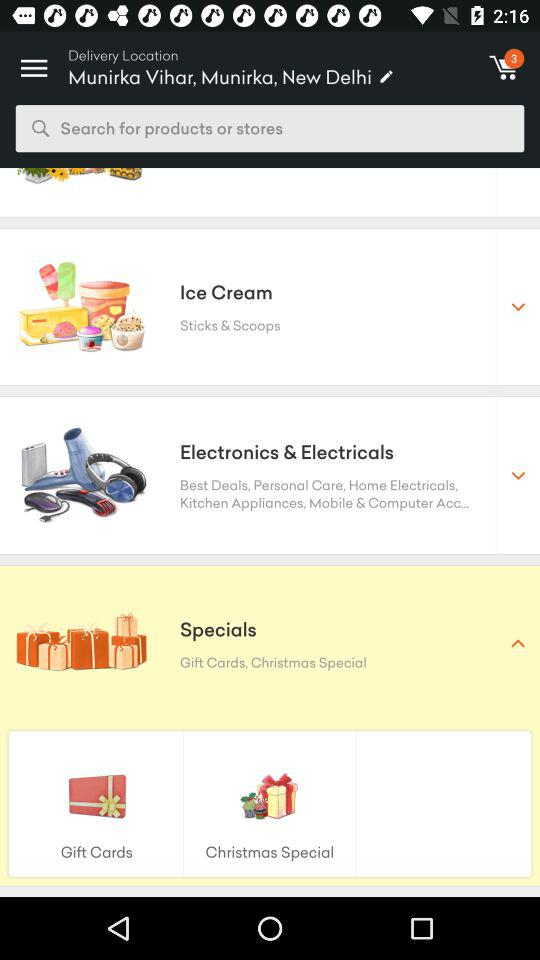What is the name of the delivery location? The delivery location is Munirka Vihar, Munirka, New Delhi. 